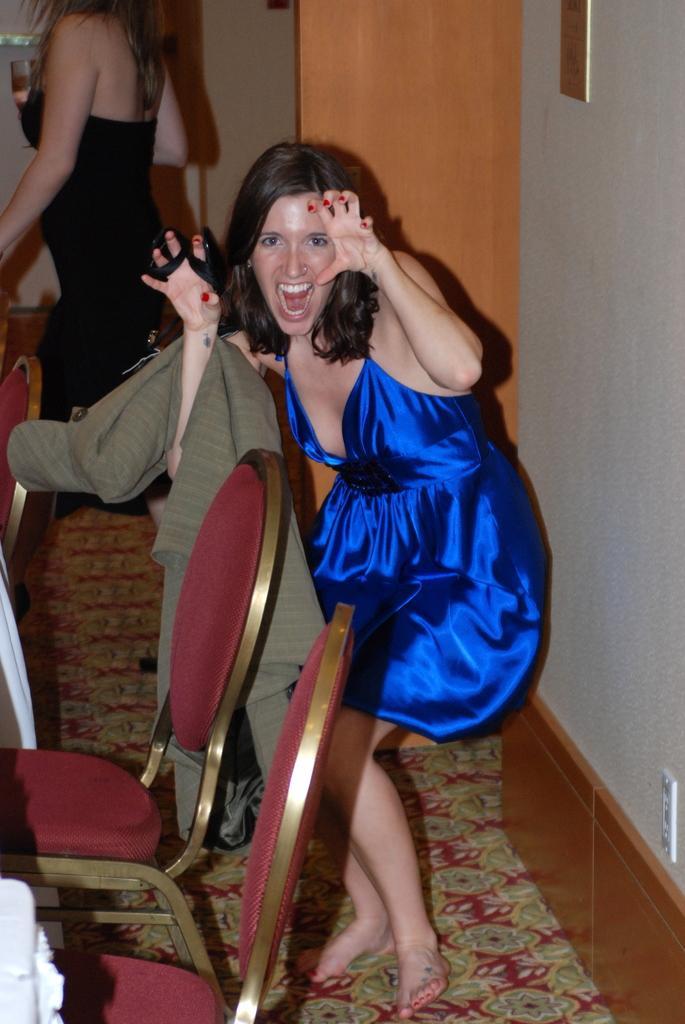Describe this image in one or two sentences. In this image I can see a person standing wearing blue color dress. Background I can see the other person standing, holding a glass and I can see few chairs in brown color. 